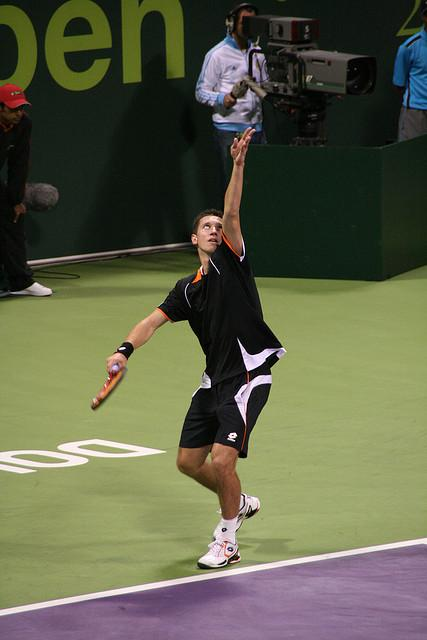What is the player about to do? Please explain your reasoning. serve. The player threw the tennis ball in the air and is about to hit it to his opponent. 